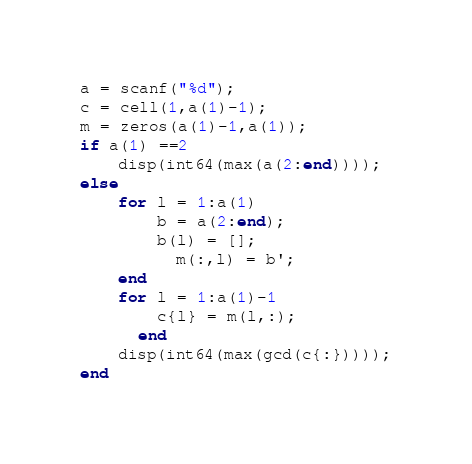Convert code to text. <code><loc_0><loc_0><loc_500><loc_500><_Octave_>a = scanf("%d");
c = cell(1,a(1)-1);
m = zeros(a(1)-1,a(1));
if a(1) ==2
	disp(int64(max(a(2:end))));
else
  	for l = 1:a(1)
      	b = a(2:end);
      	b(l) = [];
     	  m(:,l) = b';
  	end
  	for l = 1:a(1)-1
      	c{l} = m(l,:);
	  end
  	disp(int64(max(gcd(c{:}))));
end</code> 